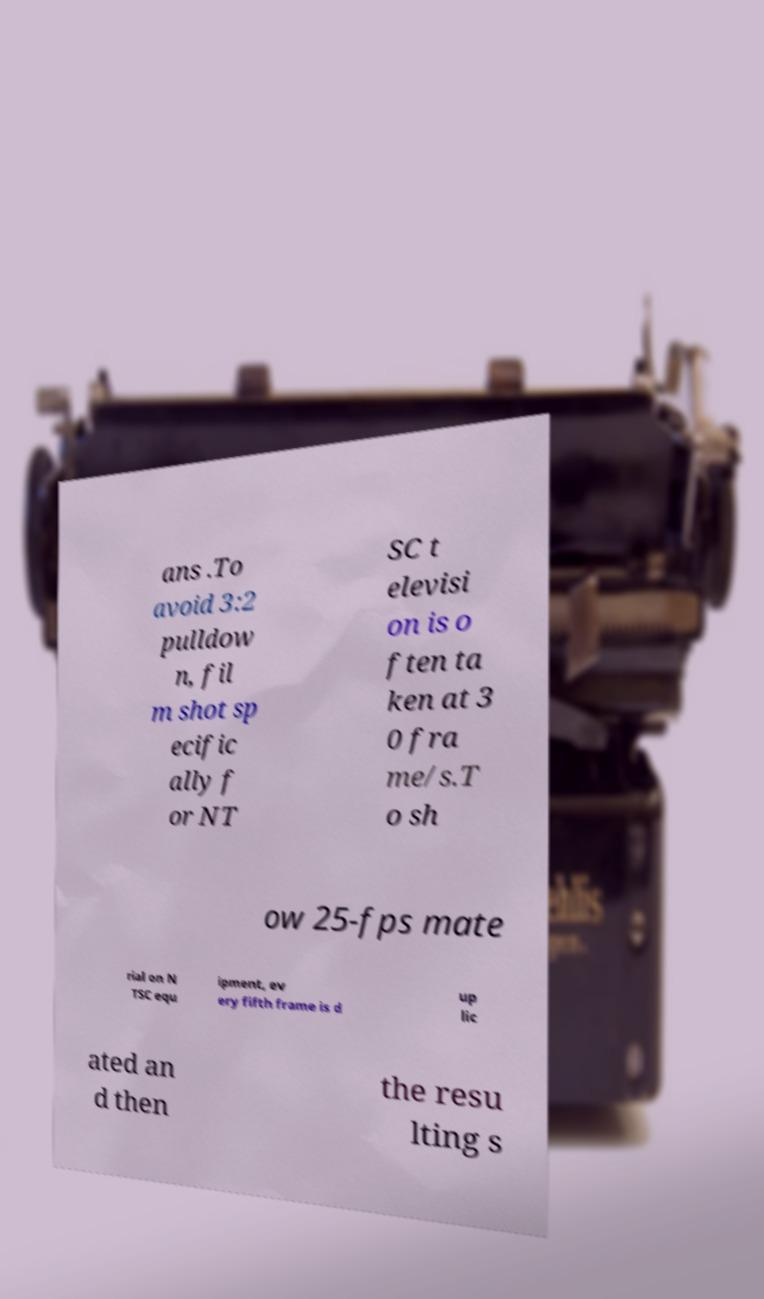What messages or text are displayed in this image? I need them in a readable, typed format. ans .To avoid 3:2 pulldow n, fil m shot sp ecific ally f or NT SC t elevisi on is o ften ta ken at 3 0 fra me/s.T o sh ow 25-fps mate rial on N TSC equ ipment, ev ery fifth frame is d up lic ated an d then the resu lting s 